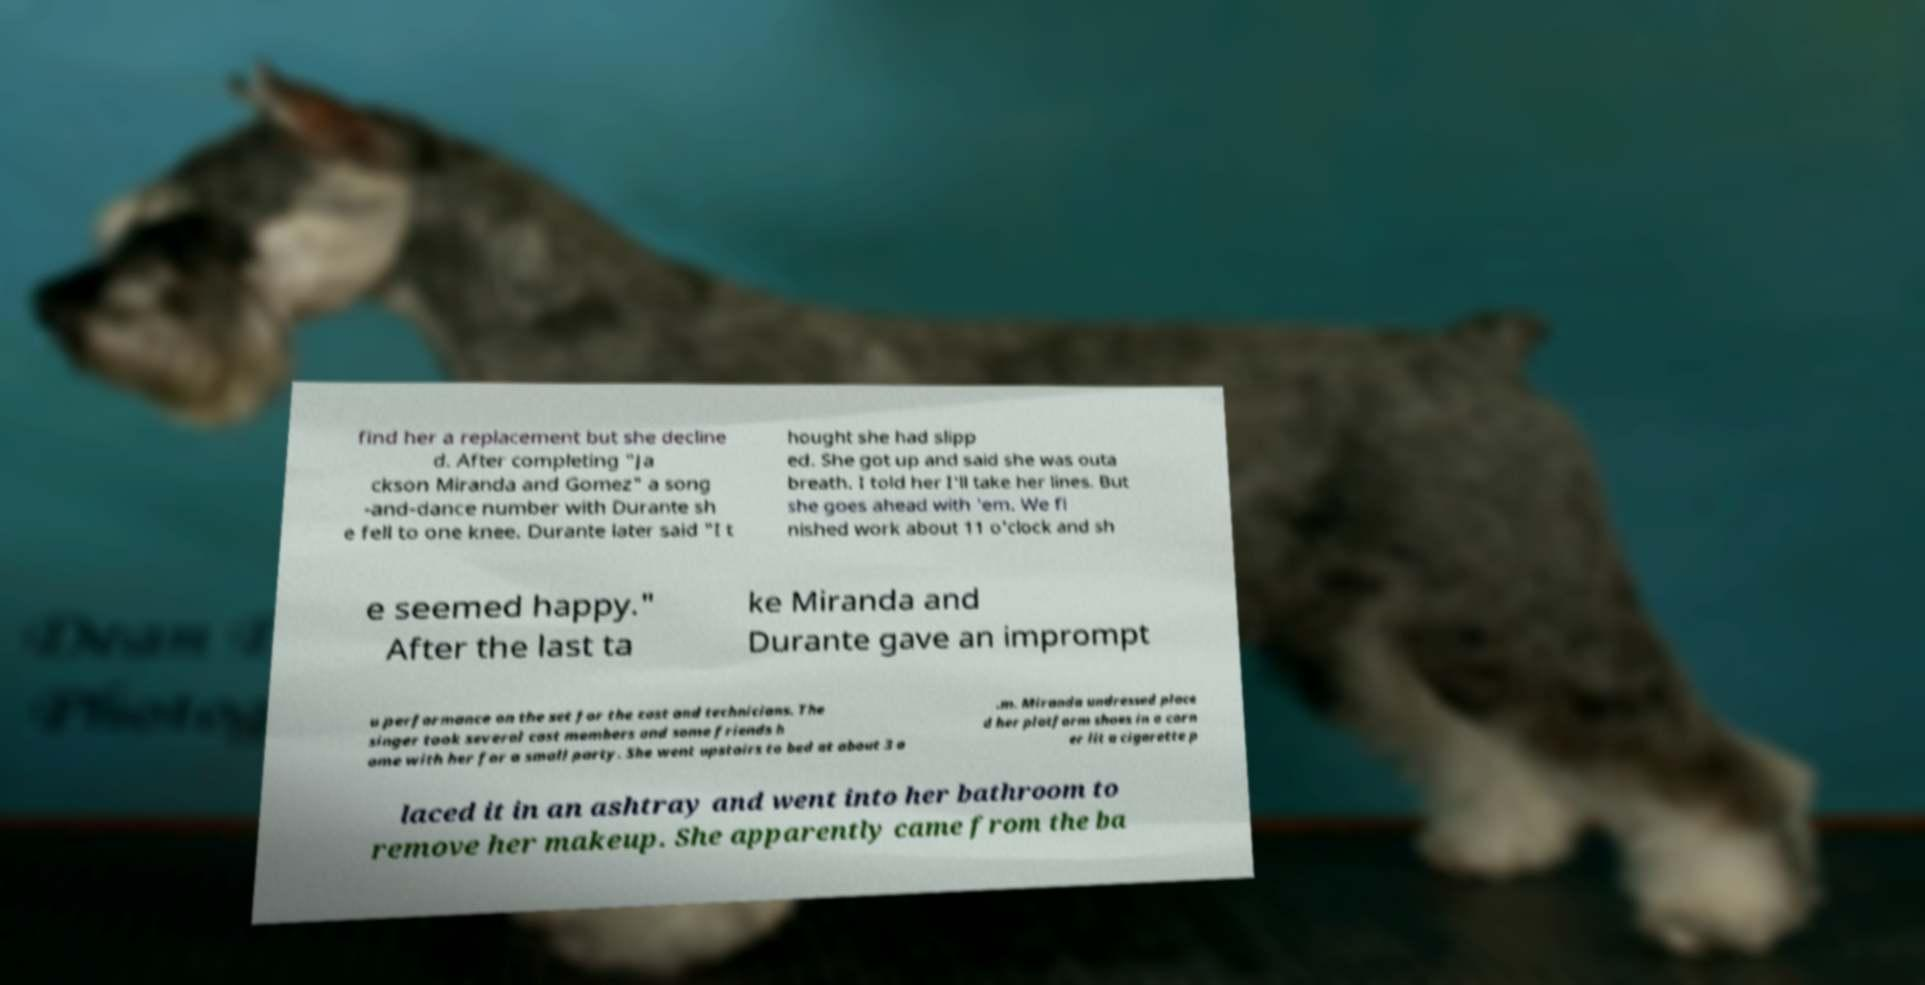For documentation purposes, I need the text within this image transcribed. Could you provide that? find her a replacement but she decline d. After completing "Ja ckson Miranda and Gomez" a song -and-dance number with Durante sh e fell to one knee. Durante later said "I t hought she had slipp ed. She got up and said she was outa breath. I told her I'll take her lines. But she goes ahead with 'em. We fi nished work about 11 o'clock and sh e seemed happy." After the last ta ke Miranda and Durante gave an imprompt u performance on the set for the cast and technicians. The singer took several cast members and some friends h ome with her for a small party. She went upstairs to bed at about 3 a .m. Miranda undressed place d her platform shoes in a corn er lit a cigarette p laced it in an ashtray and went into her bathroom to remove her makeup. She apparently came from the ba 